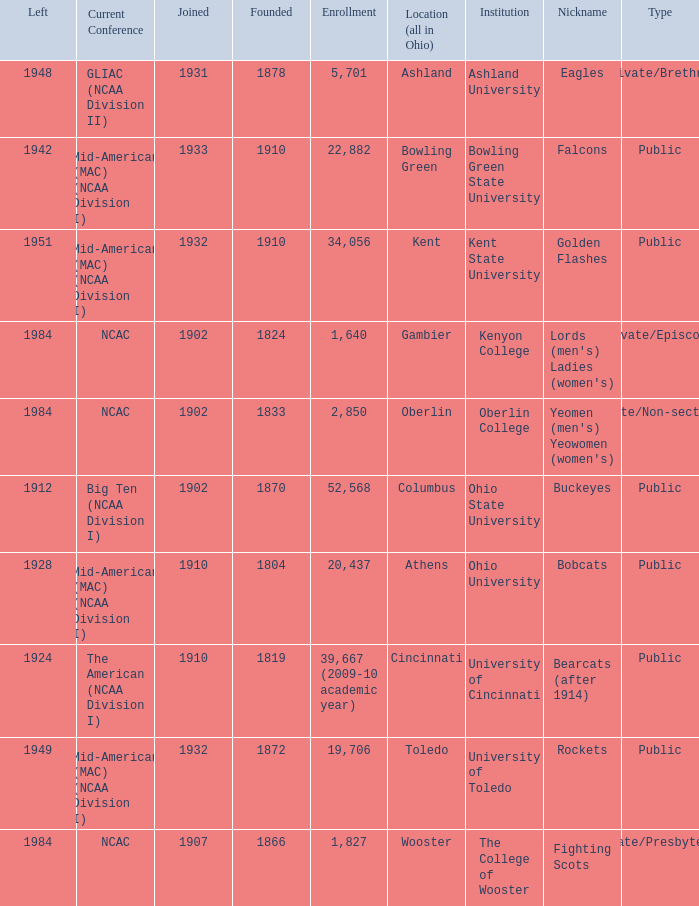What is the enrollment for Ashland University? 5701.0. 